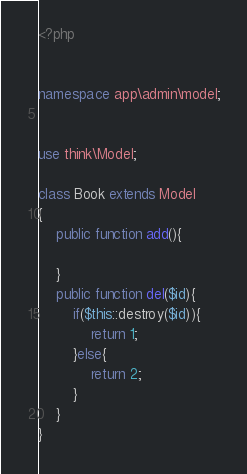Convert code to text. <code><loc_0><loc_0><loc_500><loc_500><_PHP_><?php


namespace app\admin\model;


use think\Model;

class Book extends Model
{
    public function add(){

    }
    public function del($id){
        if($this::destroy($id)){
            return 1;
        }else{
            return 2;
        }
    }
}</code> 